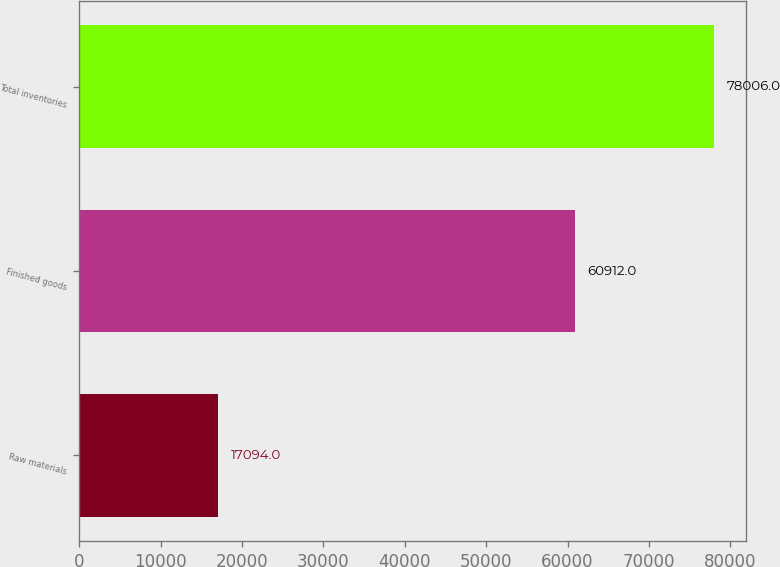<chart> <loc_0><loc_0><loc_500><loc_500><bar_chart><fcel>Raw materials<fcel>Finished goods<fcel>Total inventories<nl><fcel>17094<fcel>60912<fcel>78006<nl></chart> 